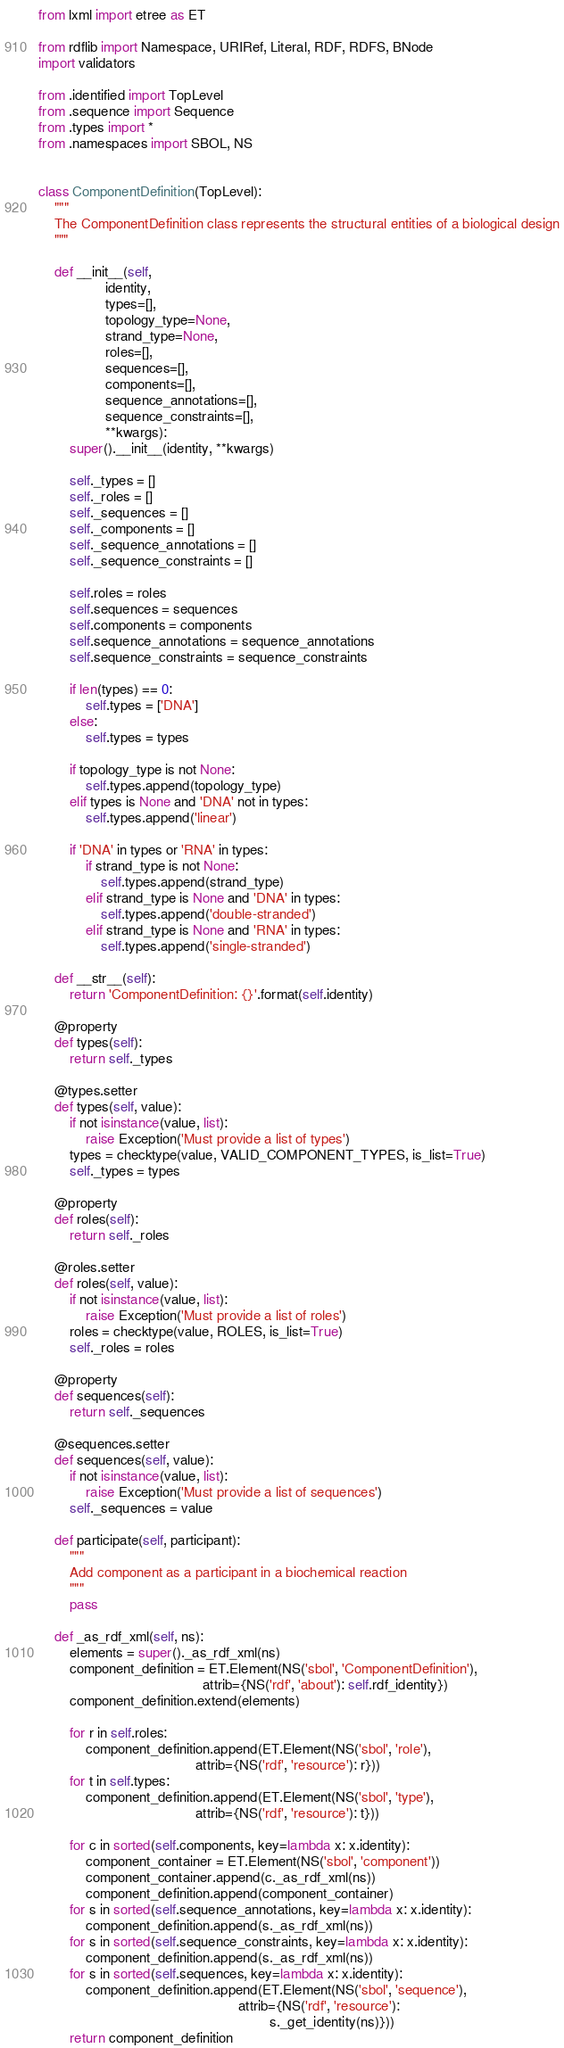<code> <loc_0><loc_0><loc_500><loc_500><_Python_>from lxml import etree as ET

from rdflib import Namespace, URIRef, Literal, RDF, RDFS, BNode
import validators

from .identified import TopLevel
from .sequence import Sequence
from .types import *
from .namespaces import SBOL, NS


class ComponentDefinition(TopLevel):
    """
    The ComponentDefinition class represents the structural entities of a biological design
    """

    def __init__(self,
                 identity,
                 types=[],
                 topology_type=None,
                 strand_type=None,
                 roles=[],
                 sequences=[],
                 components=[],
                 sequence_annotations=[],
                 sequence_constraints=[],
                 **kwargs):
        super().__init__(identity, **kwargs)

        self._types = []
        self._roles = []
        self._sequences = []
        self._components = []
        self._sequence_annotations = []
        self._sequence_constraints = []

        self.roles = roles
        self.sequences = sequences
        self.components = components
        self.sequence_annotations = sequence_annotations
        self.sequence_constraints = sequence_constraints

        if len(types) == 0:
            self.types = ['DNA']
        else:
            self.types = types

        if topology_type is not None:
            self.types.append(topology_type)
        elif types is None and 'DNA' not in types:
            self.types.append('linear')

        if 'DNA' in types or 'RNA' in types:
            if strand_type is not None:
                self.types.append(strand_type)
            elif strand_type is None and 'DNA' in types:
                self.types.append('double-stranded')
            elif strand_type is None and 'RNA' in types:
                self.types.append('single-stranded')

    def __str__(self):
        return 'ComponentDefinition: {}'.format(self.identity)

    @property
    def types(self):
        return self._types

    @types.setter
    def types(self, value):
        if not isinstance(value, list):
            raise Exception('Must provide a list of types')
        types = checktype(value, VALID_COMPONENT_TYPES, is_list=True)
        self._types = types

    @property
    def roles(self):
        return self._roles

    @roles.setter
    def roles(self, value):
        if not isinstance(value, list):
            raise Exception('Must provide a list of roles')
        roles = checktype(value, ROLES, is_list=True)
        self._roles = roles

    @property
    def sequences(self):
        return self._sequences

    @sequences.setter
    def sequences(self, value):
        if not isinstance(value, list):
            raise Exception('Must provide a list of sequences')
        self._sequences = value

    def participate(self, participant):
        """
        Add component as a participant in a biochemical reaction
        """
        pass

    def _as_rdf_xml(self, ns):
        elements = super()._as_rdf_xml(ns)
        component_definition = ET.Element(NS('sbol', 'ComponentDefinition'),
                                          attrib={NS('rdf', 'about'): self.rdf_identity})
        component_definition.extend(elements)

        for r in self.roles:
            component_definition.append(ET.Element(NS('sbol', 'role'),
                                        attrib={NS('rdf', 'resource'): r}))
        for t in self.types:
            component_definition.append(ET.Element(NS('sbol', 'type'),
                                        attrib={NS('rdf', 'resource'): t}))

        for c in sorted(self.components, key=lambda x: x.identity):
            component_container = ET.Element(NS('sbol', 'component'))
            component_container.append(c._as_rdf_xml(ns))
            component_definition.append(component_container)
        for s in sorted(self.sequence_annotations, key=lambda x: x.identity):
            component_definition.append(s._as_rdf_xml(ns))
        for s in sorted(self.sequence_constraints, key=lambda x: x.identity):
            component_definition.append(s._as_rdf_xml(ns))
        for s in sorted(self.sequences, key=lambda x: x.identity):
            component_definition.append(ET.Element(NS('sbol', 'sequence'),
                                                   attrib={NS('rdf', 'resource'):
                                                           s._get_identity(ns)}))
        return component_definition
</code> 